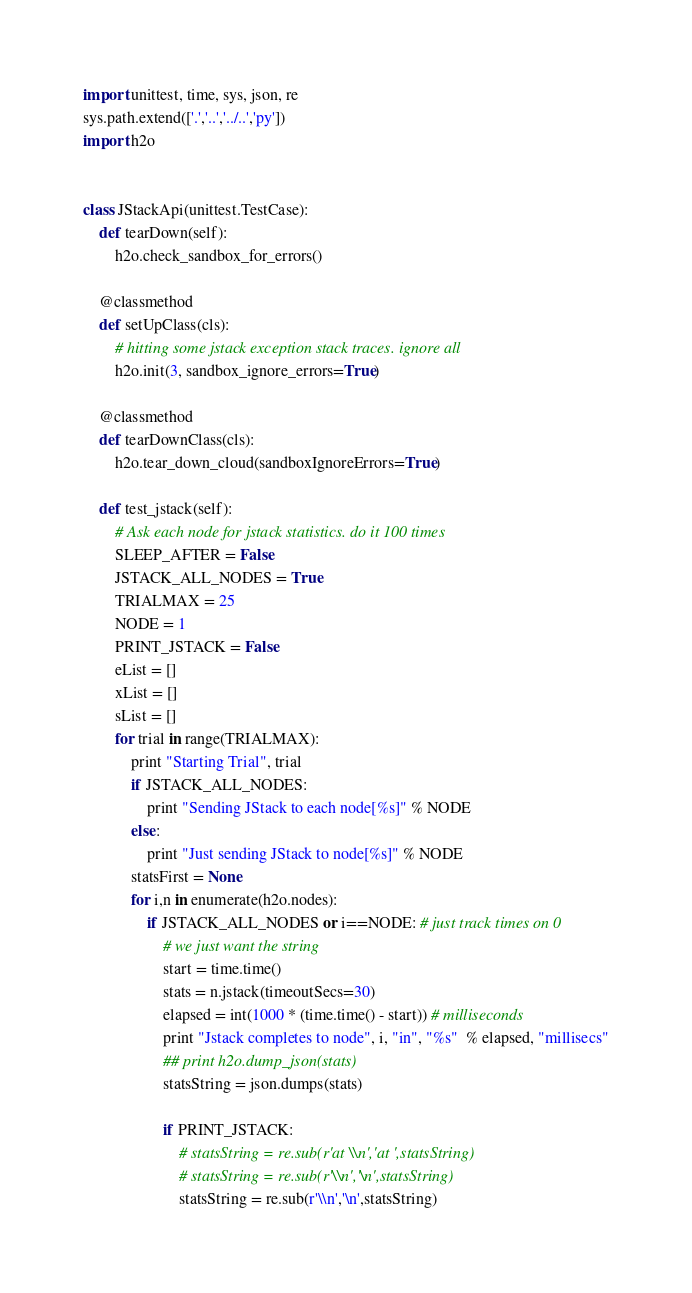Convert code to text. <code><loc_0><loc_0><loc_500><loc_500><_Python_>import unittest, time, sys, json, re
sys.path.extend(['.','..','../..','py'])
import h2o


class JStackApi(unittest.TestCase):
    def tearDown(self):
        h2o.check_sandbox_for_errors()

    @classmethod
    def setUpClass(cls):
        # hitting some jstack exception stack traces. ignore all
        h2o.init(3, sandbox_ignore_errors=True)

    @classmethod
    def tearDownClass(cls):
        h2o.tear_down_cloud(sandboxIgnoreErrors=True)

    def test_jstack(self):
        # Ask each node for jstack statistics. do it 100 times
        SLEEP_AFTER = False
        JSTACK_ALL_NODES = True
        TRIALMAX = 25
        NODE = 1
        PRINT_JSTACK = False
        eList = []
        xList = []
        sList = []
        for trial in range(TRIALMAX):
            print "Starting Trial", trial
            if JSTACK_ALL_NODES:
                print "Sending JStack to each node[%s]" % NODE
            else:
                print "Just sending JStack to node[%s]" % NODE
            statsFirst = None
            for i,n in enumerate(h2o.nodes):
                if JSTACK_ALL_NODES or i==NODE: # just track times on 0
                    # we just want the string
                    start = time.time()
                    stats = n.jstack(timeoutSecs=30)
                    elapsed = int(1000 * (time.time() - start)) # milliseconds
                    print "Jstack completes to node", i, "in", "%s"  % elapsed, "millisecs"
                    ## print h2o.dump_json(stats)
                    statsString = json.dumps(stats)

                    if PRINT_JSTACK:
                        # statsString = re.sub(r'at \\n','at ',statsString)
                        # statsString = re.sub(r'\\n','\n',statsString)
                        statsString = re.sub(r'\\n','\n',statsString)</code> 